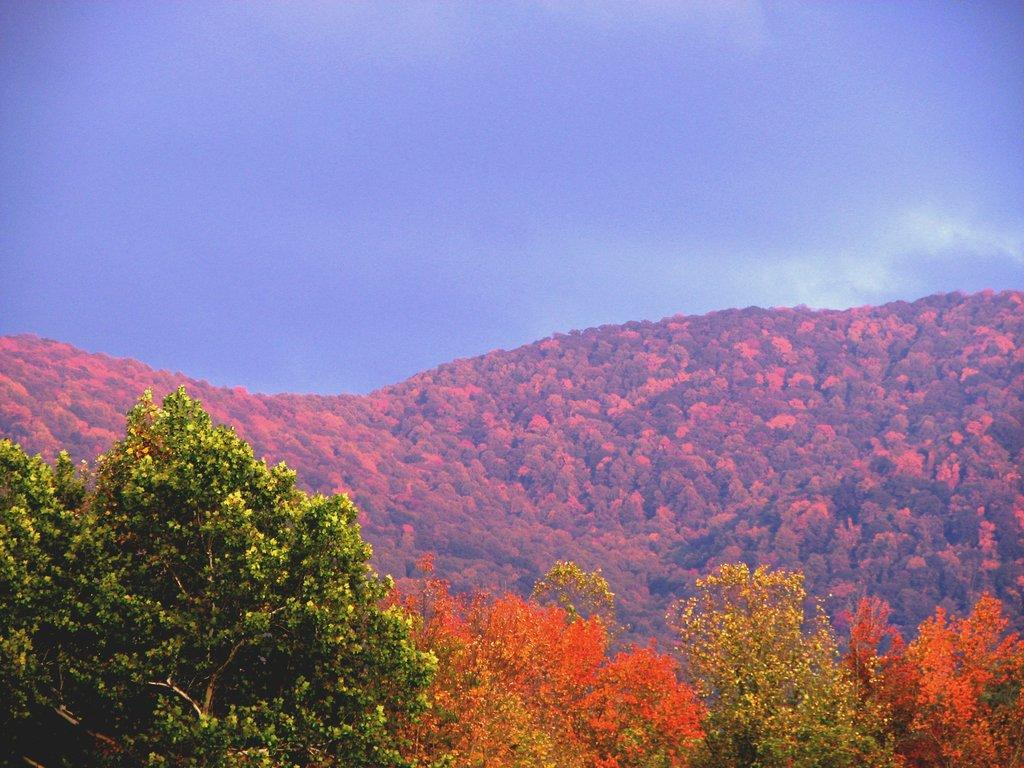What type of natural features can be seen in the image? There are trees and mountains in the image. What is visible in the background of the image? The sky is visible in the background of the image. What can be observed in the sky? Clouds are present in the sky. What message does the queen send in the letter depicted in the image? There is no queen or letter present in the image; it features trees, mountains, and a sky with clouds. 